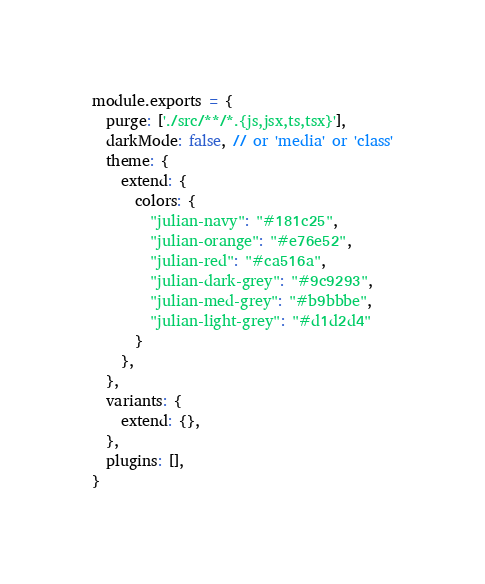Convert code to text. <code><loc_0><loc_0><loc_500><loc_500><_JavaScript_>module.exports = {
  purge: ['./src/**/*.{js,jsx,ts,tsx}'],
  darkMode: false, // or 'media' or 'class'
  theme: {
    extend: {
      colors: {
        "julian-navy": "#181c25",
        "julian-orange": "#e76e52",
        "julian-red": "#ca516a",
        "julian-dark-grey": "#9c9293",
        "julian-med-grey": "#b9bbbe",
        "julian-light-grey": "#d1d2d4"
      }
    },
  },
  variants: {
    extend: {},
  },
  plugins: [],
}
</code> 